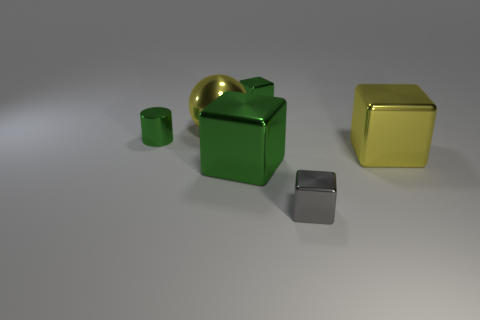Are there any large shiny spheres that are on the left side of the small green shiny object that is on the right side of the big green metallic cube?
Keep it short and to the point. Yes. There is a cylinder on the left side of the gray shiny cube; is it the same color as the big object behind the large yellow block?
Your answer should be compact. No. There is another shiny block that is the same size as the yellow shiny block; what is its color?
Keep it short and to the point. Green. Is the number of yellow metallic things that are in front of the small gray shiny cube the same as the number of small green shiny cubes on the right side of the large green shiny block?
Your answer should be very brief. No. What material is the big object that is on the right side of the small thing that is behind the small cylinder?
Offer a very short reply. Metal. How many things are big yellow metal objects or cubes?
Your response must be concise. 5. There is a cube that is the same color as the ball; what is its size?
Keep it short and to the point. Large. Are there fewer things than large metal spheres?
Your answer should be compact. No. There is a sphere that is the same material as the small gray cube; what is its size?
Make the answer very short. Large. The green metallic cylinder is what size?
Provide a short and direct response. Small. 